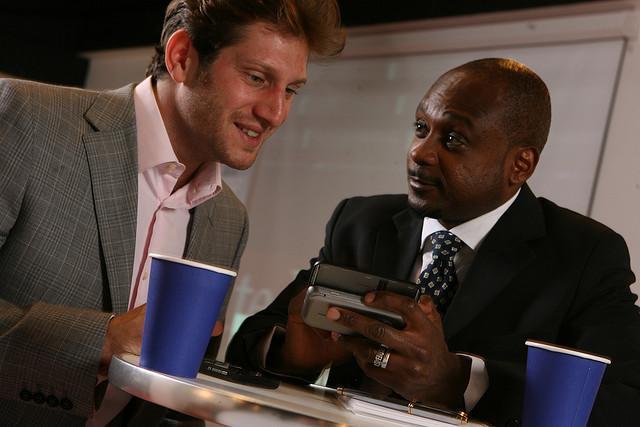How many men are wearing ties?
Give a very brief answer. 1. How many cups are in the picture?
Give a very brief answer. 2. How many people can be seen?
Give a very brief answer. 2. How many ties can you see?
Give a very brief answer. 1. 